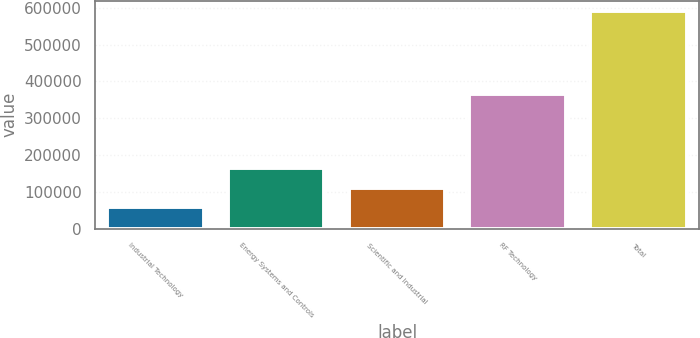<chart> <loc_0><loc_0><loc_500><loc_500><bar_chart><fcel>Industrial Technology<fcel>Energy Systems and Controls<fcel>Scientific and Industrial<fcel>RF Technology<fcel>Total<nl><fcel>59128<fcel>165265<fcel>112197<fcel>365669<fcel>589814<nl></chart> 